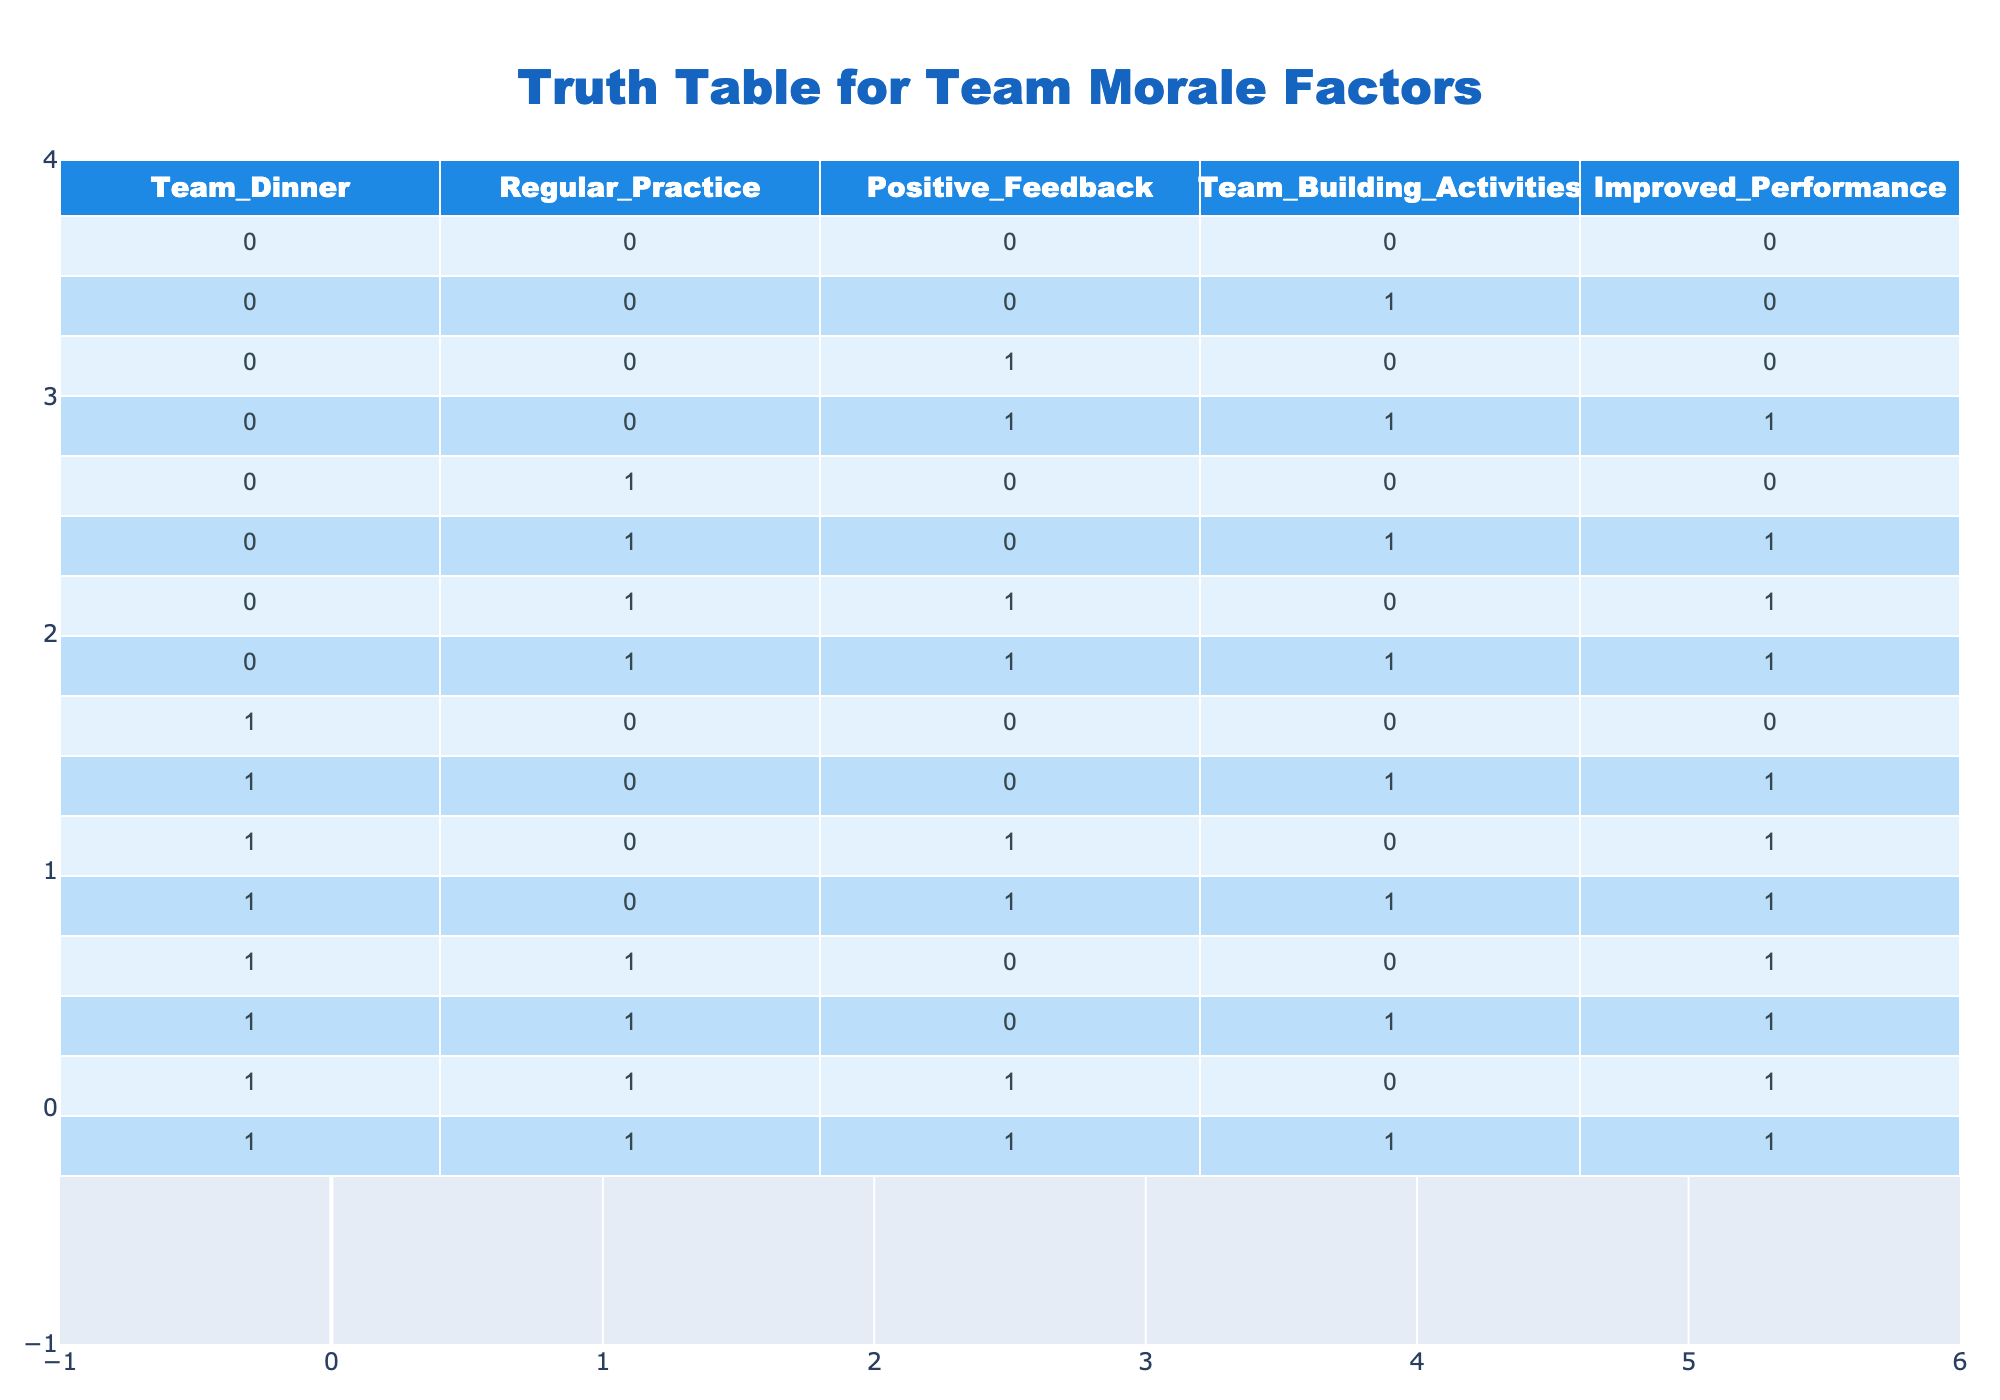What is the performance when there are team dinners and no positive feedback? From the table, we look for the row where Team_Dinner is 1 and Positive_Feedback is 0. The matching row is (1, 0, 0, 0), which shows Improved_Performance is 0.
Answer: 0 How many rows indicate an improvement in performance when regular practice is combined with team-building activities? We check the rows where Regular_Practice is 1 and Team_Building_Activities is also 1. These rows are (0, 1, 1, 1) and (1, 1, 1, 1), both show Improved_Performance as 1. Thus, there are 2 rows where performance improves.
Answer: 2 If there is regular practice and positive feedback, what is the overall performance? We find the rows where Regular_Practice is 1 and Positive_Feedback is also 1. The rows that match are (1, 1, 0, 0), (1, 1, 0, 1), (1, 1, 1, 0), and (1, 1, 1, 1); all of them indicate Improved_Performance as 1. Thus, the overall performance with these conditions is high.
Answer: 1 Does team dinner always lead to improved performance? We check all rows where Team_Dinner is 1. The outputs for Improved_Performance are (0, 1, 1, 1, 1). As there are rows where the performance is 0, we conclude that team dinner does not always lead to improved performance.
Answer: No What is the total number of instances where no feedback was given but team dinners occurred? Find the rows where Team_Dinner is 1 and Positive_Feedback is 0. The matching rows are (1, 0, 0, 0), (1, 0, 1, 0). This gives us 2 instances that meet the criteria.
Answer: 2 What percentage of practices that included positive feedback led to improved performance? We first find the total rows with Positive_Feedback as 1, which are 8 (at index: 2, 3, 5, 6, 7, 11, 13, 14). Next, 6 of these rows have Improved_Performance as 1. So, (6/8) * 100 = 75% led to improvement.
Answer: 75% Is there any case where team-building activities were present without improvement in performance? Looking for rows where Team_Building_Activities is 1 and Improved_Performance is 0. The rows matching this condition are none, since all rows with team-building activities show Improved_Performance as either 1 or null. So this statement is false.
Answer: No When both regular practice and team-building activities are implemented, how often is the performance improved? The relevant rows have Regular_Practice and Team_Building_Activities both as 1. These are (0, 1, 1, 1), (1, 1, 1, 1). Both indicate Improved_Performance as 1. Therefore, improvement occurs 2 out of the 2 times these conditions are met, implying a 100% improvement rate in this scenario.
Answer: 100% 